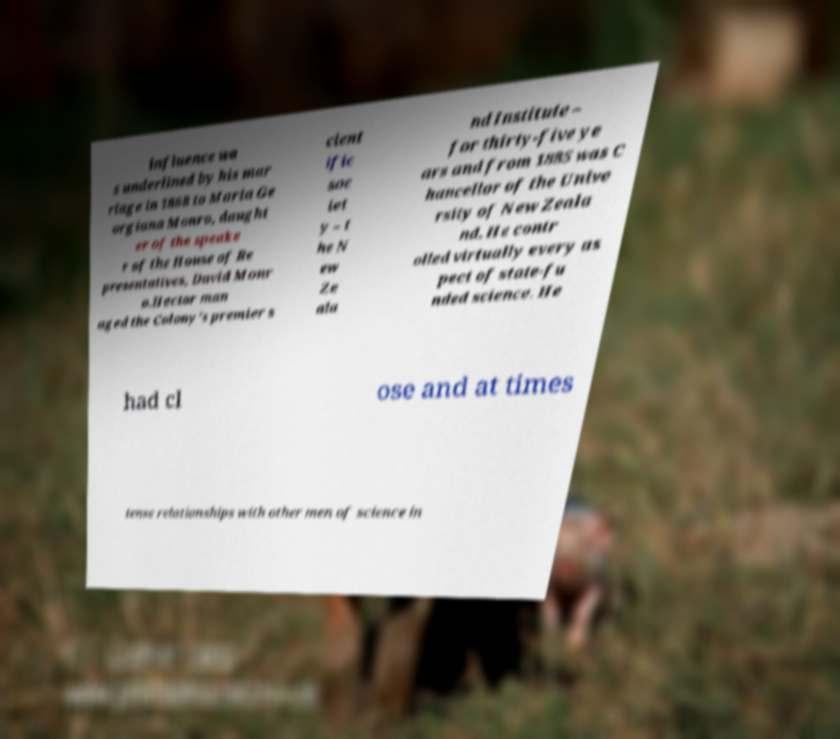Can you read and provide the text displayed in the image?This photo seems to have some interesting text. Can you extract and type it out for me? influence wa s underlined by his mar riage in 1868 to Maria Ge orgiana Monro, daught er of the speake r of the House of Re presentatives, David Monr o.Hector man aged the Colony's premier s cient ific soc iet y – t he N ew Ze ala nd Institute – for thirty-five ye ars and from 1885 was C hancellor of the Unive rsity of New Zeala nd. He contr olled virtually every as pect of state-fu nded science. He had cl ose and at times tense relationships with other men of science in 